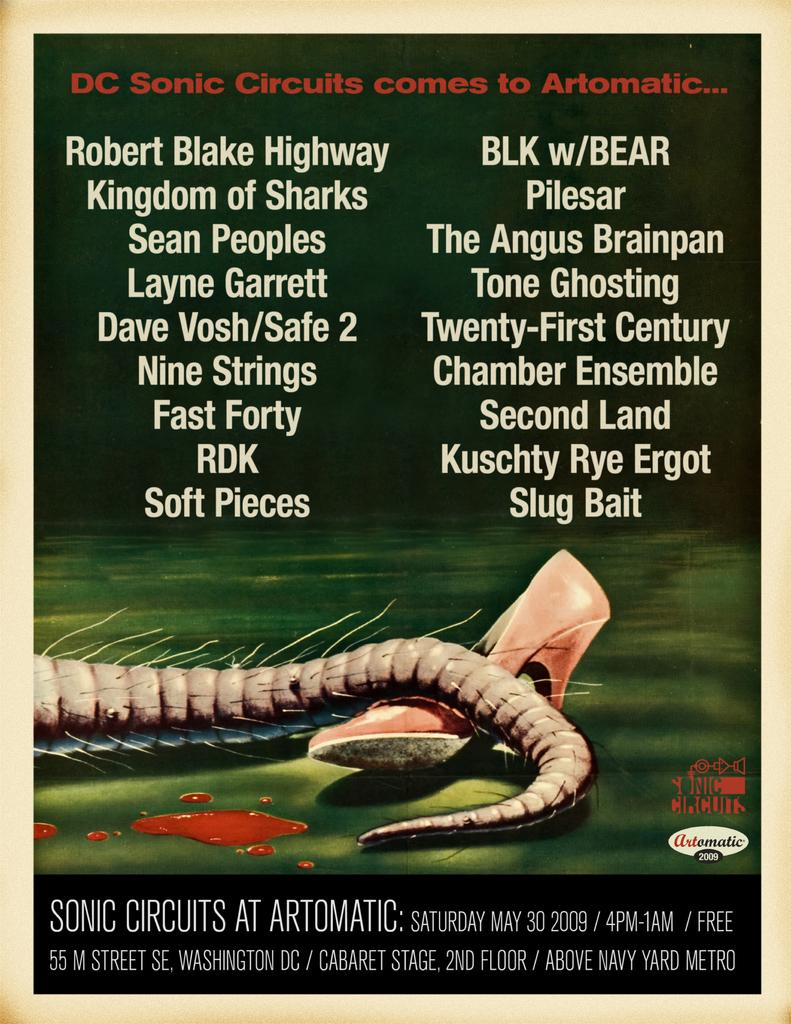What is the main subject of the poster in the image? The poster contains an image of an animal tail. Are there any other images on the poster besides the animal tail? Yes, there is an image of footwear on the poster. Is there any text on the poster? Yes, there is text written on the poster. Where is the toothbrush located in the image? There is no toothbrush present in the image. What type of bedroom is shown in the image? There is no bedroom shown in the image; it only features a poster. 